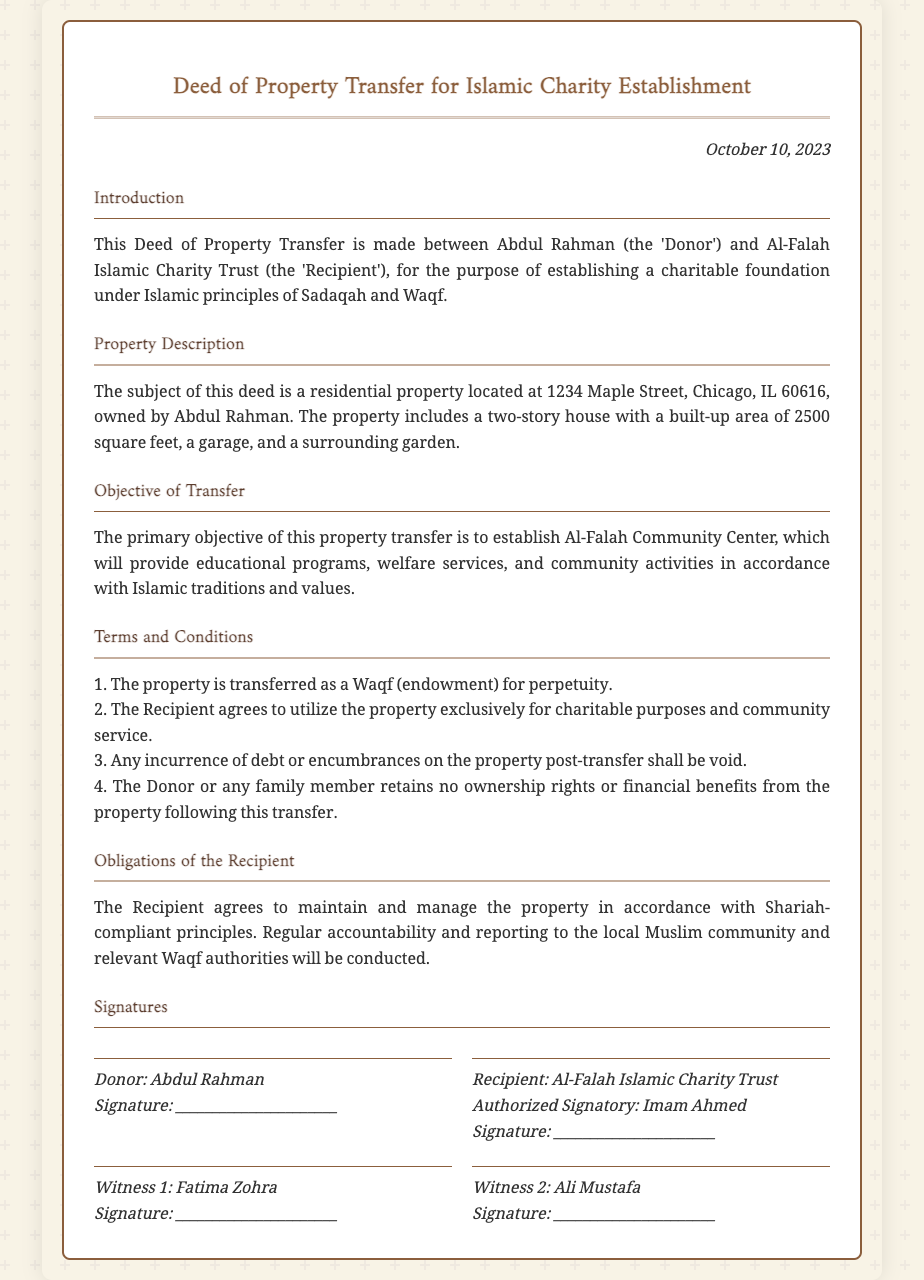What is the date of the deed? The date mentioned in the deed is when it was signed and is stated clearly at the top of the document.
Answer: October 10, 2023 Who is the donor? The donor's name is specified in the introduction section of the deed.
Answer: Abdul Rahman What is the address of the property? The deed provides a detailed description of the property location, which includes the street name and city.
Answer: 1234 Maple Street, Chicago, IL 60616 What does the property transfer aim to establish? The objective of the property transfer is explicitly mentioned in the "Objective of Transfer" section.
Answer: Al-Falah Community Center How many conditions are stated under "Terms and Conditions"? The number of conditions is explicitly listed in the "Terms and Conditions" section of the deed.
Answer: 4 Who is the authorized signatory for the recipient? The document specifies a person who is designated to sign on behalf of the recipient organization.
Answer: Imam Ahmed What is the primary purpose of the Al-Falah Community Center? The purpose is clearly articulated in the objective section of the deed.
Answer: Provide educational programs, welfare services, and community activities What role does the recipient play regarding property management? The obligations of the recipient regarding the management of the property are noted in the respective section of the deed.
Answer: Maintain and manage the property What type of transfer is the property? The deed classifies the type of transfer under specific terms.
Answer: Waqf 